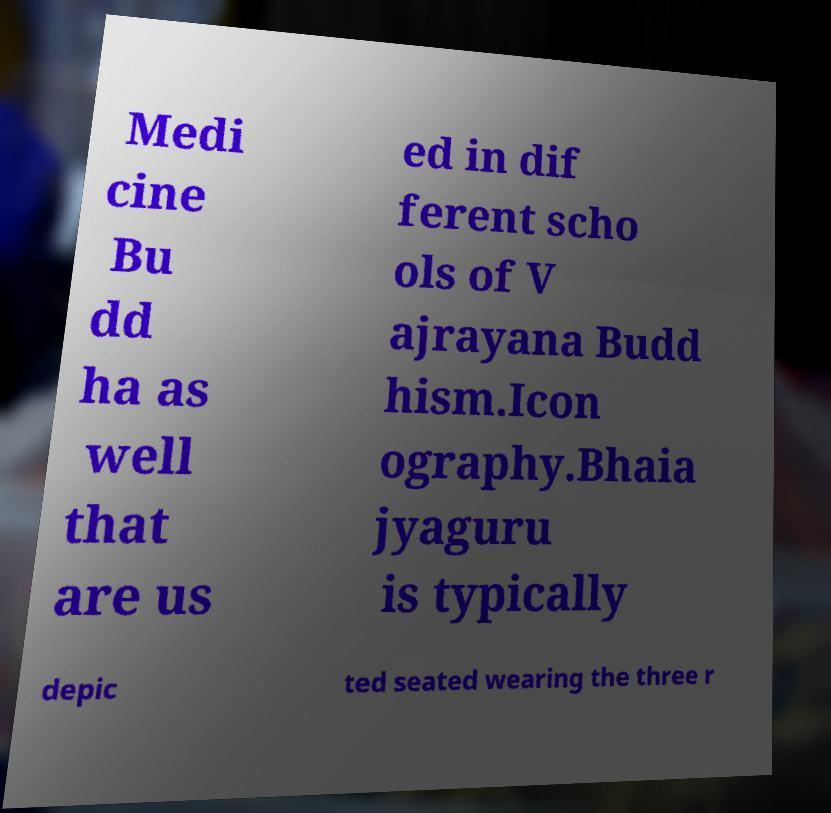Could you assist in decoding the text presented in this image and type it out clearly? Medi cine Bu dd ha as well that are us ed in dif ferent scho ols of V ajrayana Budd hism.Icon ography.Bhaia jyaguru is typically depic ted seated wearing the three r 